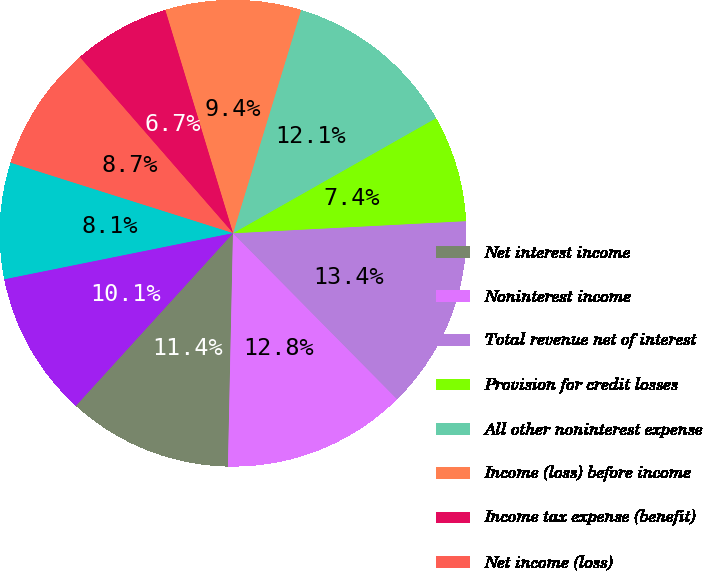Convert chart. <chart><loc_0><loc_0><loc_500><loc_500><pie_chart><fcel>Net interest income<fcel>Noninterest income<fcel>Total revenue net of interest<fcel>Provision for credit losses<fcel>All other noninterest expense<fcel>Income (loss) before income<fcel>Income tax expense (benefit)<fcel>Net income (loss)<fcel>Net income (loss) applicable<fcel>Average common shares issued<nl><fcel>11.41%<fcel>12.75%<fcel>13.42%<fcel>7.38%<fcel>12.08%<fcel>9.4%<fcel>6.71%<fcel>8.72%<fcel>8.05%<fcel>10.07%<nl></chart> 